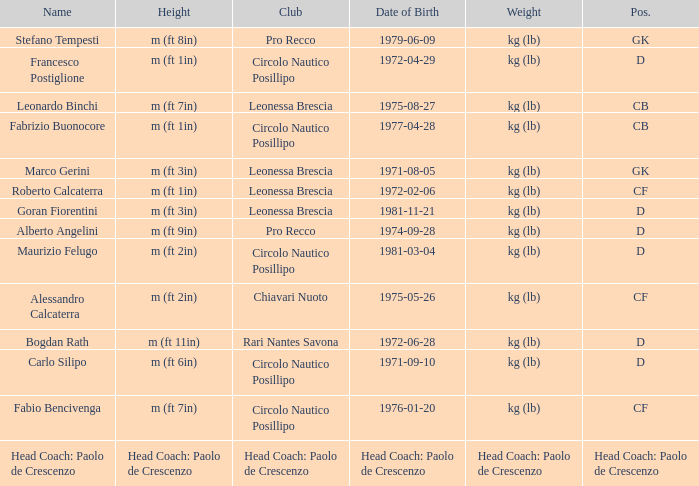What is the position of the player with a height of m (ft 6in)? D. 